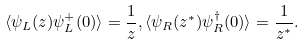Convert formula to latex. <formula><loc_0><loc_0><loc_500><loc_500>\langle \psi _ { L } ( z ) \psi _ { L } ^ { + } ( 0 ) \rangle = \frac { 1 } { z } , \langle \psi _ { R } ( z ^ { * } ) \psi _ { R } ^ { \dagger } ( 0 ) \rangle = \frac { 1 } { z ^ { * } } .</formula> 